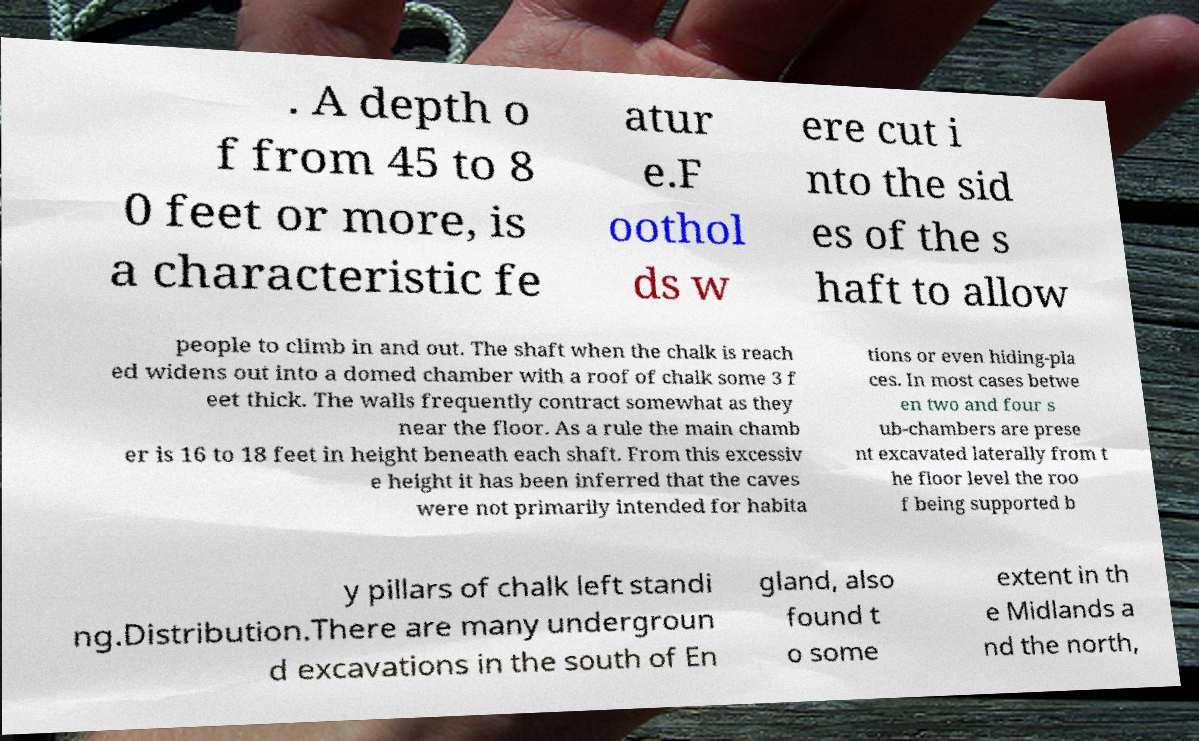Can you accurately transcribe the text from the provided image for me? . A depth o f from 45 to 8 0 feet or more, is a characteristic fe atur e.F oothol ds w ere cut i nto the sid es of the s haft to allow people to climb in and out. The shaft when the chalk is reach ed widens out into a domed chamber with a roof of chalk some 3 f eet thick. The walls frequently contract somewhat as they near the floor. As a rule the main chamb er is 16 to 18 feet in height beneath each shaft. From this excessiv e height it has been inferred that the caves were not primarily intended for habita tions or even hiding-pla ces. In most cases betwe en two and four s ub-chambers are prese nt excavated laterally from t he floor level the roo f being supported b y pillars of chalk left standi ng.Distribution.There are many undergroun d excavations in the south of En gland, also found t o some extent in th e Midlands a nd the north, 